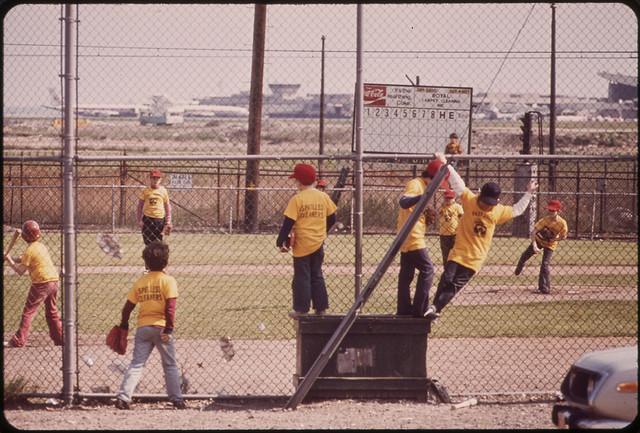How many people are visible?
Give a very brief answer. 6. How many cars can you see?
Give a very brief answer. 1. 